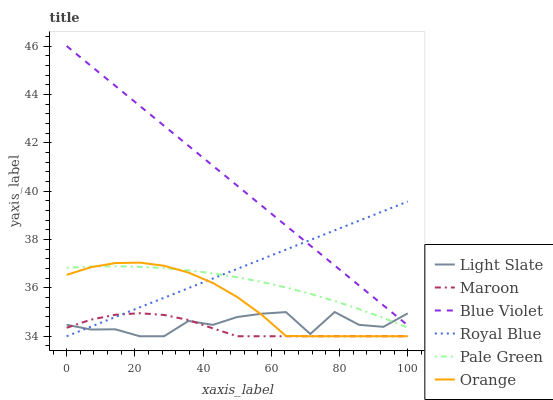Does Maroon have the minimum area under the curve?
Answer yes or no. Yes. Does Blue Violet have the maximum area under the curve?
Answer yes or no. Yes. Does Royal Blue have the minimum area under the curve?
Answer yes or no. No. Does Royal Blue have the maximum area under the curve?
Answer yes or no. No. Is Royal Blue the smoothest?
Answer yes or no. Yes. Is Light Slate the roughest?
Answer yes or no. Yes. Is Maroon the smoothest?
Answer yes or no. No. Is Maroon the roughest?
Answer yes or no. No. Does Pale Green have the lowest value?
Answer yes or no. No. Does Blue Violet have the highest value?
Answer yes or no. Yes. Does Royal Blue have the highest value?
Answer yes or no. No. Is Maroon less than Blue Violet?
Answer yes or no. Yes. Is Pale Green greater than Maroon?
Answer yes or no. Yes. Does Pale Green intersect Light Slate?
Answer yes or no. Yes. Is Pale Green less than Light Slate?
Answer yes or no. No. Is Pale Green greater than Light Slate?
Answer yes or no. No. Does Maroon intersect Blue Violet?
Answer yes or no. No. 